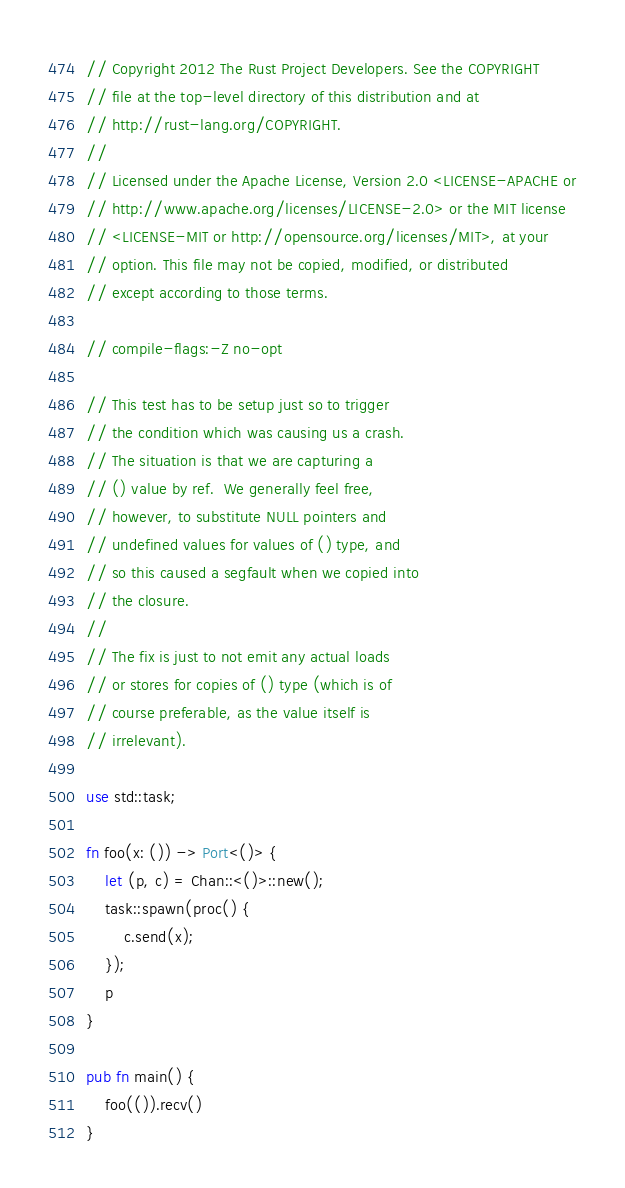<code> <loc_0><loc_0><loc_500><loc_500><_Rust_>// Copyright 2012 The Rust Project Developers. See the COPYRIGHT
// file at the top-level directory of this distribution and at
// http://rust-lang.org/COPYRIGHT.
//
// Licensed under the Apache License, Version 2.0 <LICENSE-APACHE or
// http://www.apache.org/licenses/LICENSE-2.0> or the MIT license
// <LICENSE-MIT or http://opensource.org/licenses/MIT>, at your
// option. This file may not be copied, modified, or distributed
// except according to those terms.

// compile-flags:-Z no-opt

// This test has to be setup just so to trigger
// the condition which was causing us a crash.
// The situation is that we are capturing a
// () value by ref.  We generally feel free,
// however, to substitute NULL pointers and
// undefined values for values of () type, and
// so this caused a segfault when we copied into
// the closure.
//
// The fix is just to not emit any actual loads
// or stores for copies of () type (which is of
// course preferable, as the value itself is
// irrelevant).

use std::task;

fn foo(x: ()) -> Port<()> {
    let (p, c) = Chan::<()>::new();
    task::spawn(proc() {
        c.send(x);
    });
    p
}

pub fn main() {
    foo(()).recv()
}
</code> 